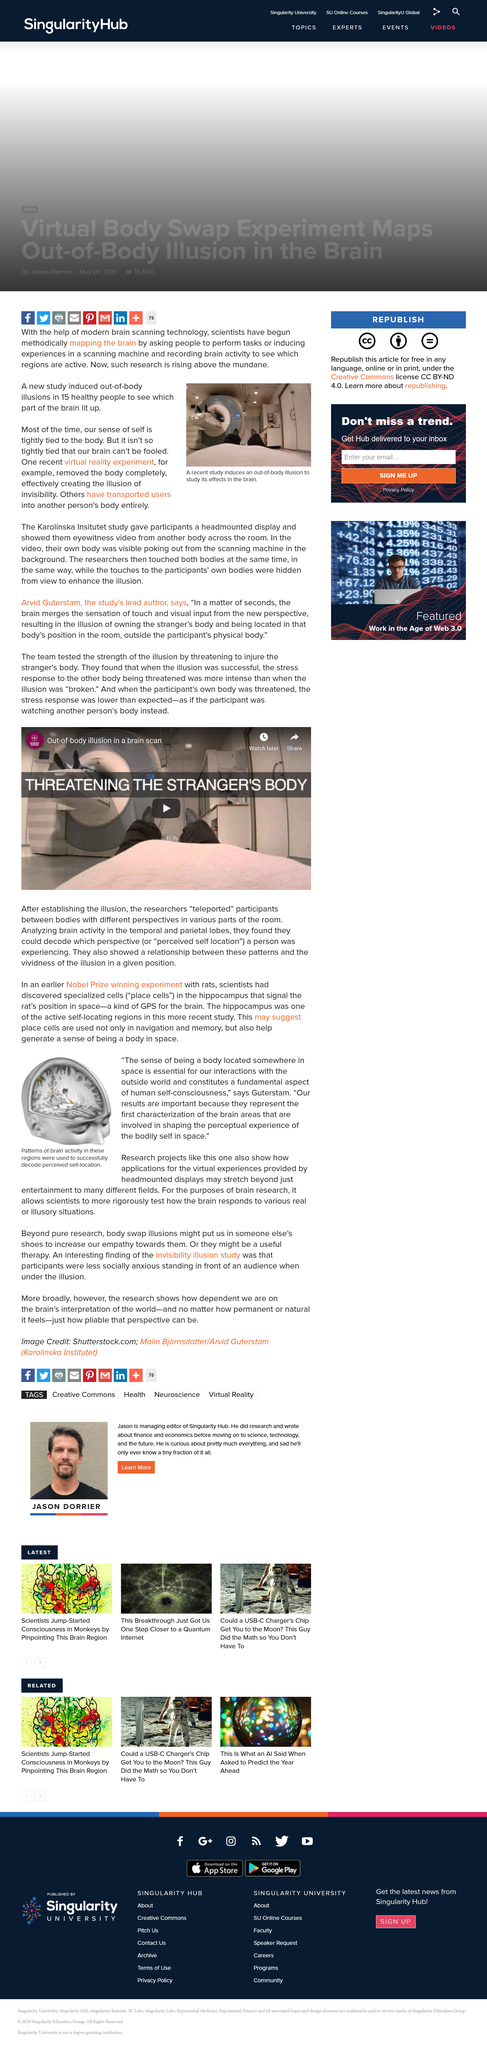Indicate a few pertinent items in this graphic. Place cells are brain cells that play a crucial role in navigation and memory. They are responsible for helping us remember and navigate our surroundings. Scientists are mapping the brain through the use of advanced brain imaging technology. The experiment has created the illusion of invisibility through the use of virtual reality, thereby challenging the perception of what is real and what is not. The experiment used rats as the type of animal. Scientists use scanning machines to map the brain, which are specialized machines designed to capture detailed images of the brain. 